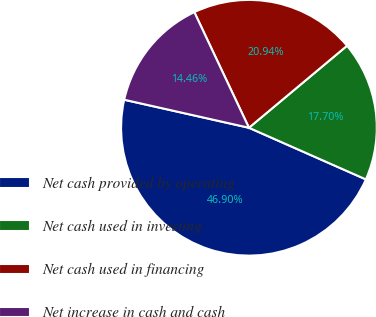Convert chart to OTSL. <chart><loc_0><loc_0><loc_500><loc_500><pie_chart><fcel>Net cash provided by operating<fcel>Net cash used in investing<fcel>Net cash used in financing<fcel>Net increase in cash and cash<nl><fcel>46.9%<fcel>17.7%<fcel>20.94%<fcel>14.46%<nl></chart> 